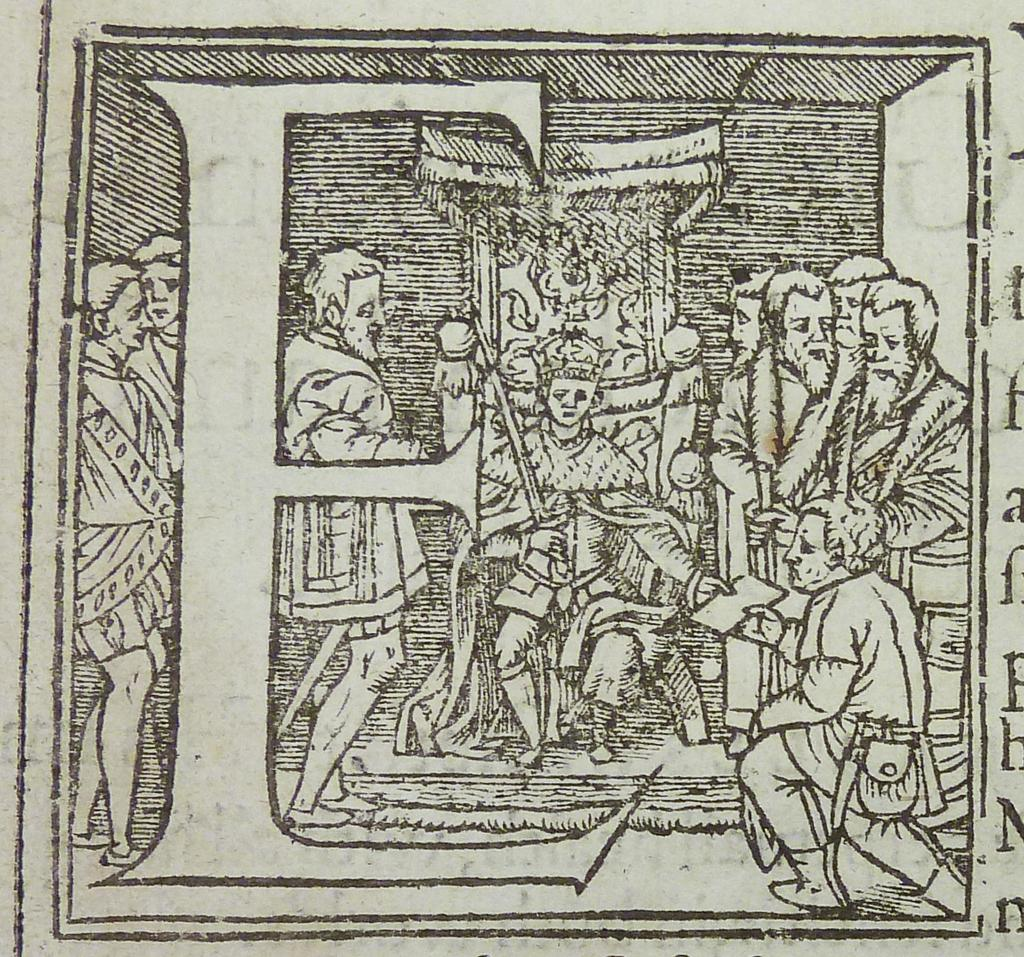What is the nature of the image? The image is a drawing. What is the main subject of the drawing? There are people in the center of the drawing. Where is the text located in the drawing? The text is on the right side of the drawing. What type of rice is being cooked by the friend in the drawing? There is no rice or friend present in the drawing; it only features people and text. What impulse might have led the artist to create this drawing? It is impossible to determine the impulse of the artist from the drawing alone. 